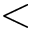Convert formula to latex. <formula><loc_0><loc_0><loc_500><loc_500><</formula> 